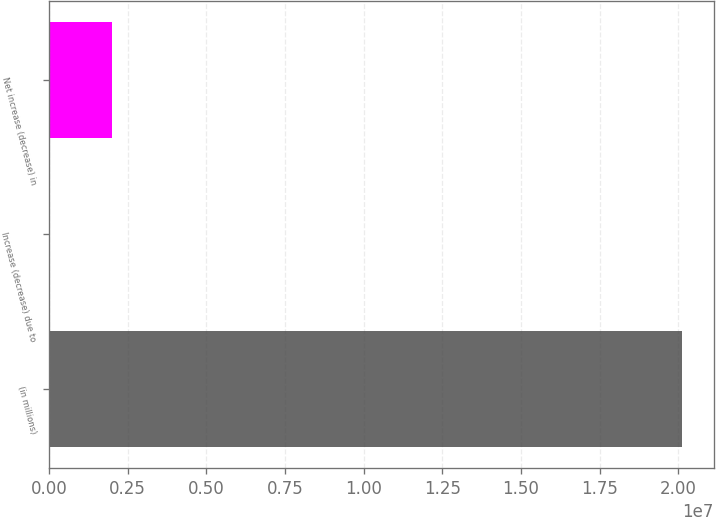Convert chart to OTSL. <chart><loc_0><loc_0><loc_500><loc_500><bar_chart><fcel>(in millions)<fcel>Increase (decrease) due to<fcel>Net increase (decrease) in<nl><fcel>2.0122e+07<fcel>61.4<fcel>2.01226e+06<nl></chart> 